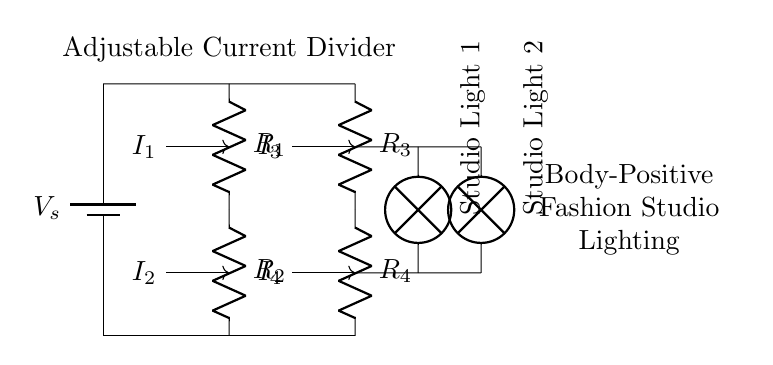What is the total number of resistors in this circuit? The diagram shows four resistors labeled as R1, R2, R3, and R4. Adding these gives a total of four resistors.
Answer: four What is the purpose of the current divider in this circuit? A current divider allows the current to be split between different branches. In this case, it adjusts the intensity of the studio lights based on the resistors' values.
Answer: adjust lighting Which component receives the most current in this circuit? Without specific resistance values, the resistor with the least resistance value would receive the most current. However, it's typically determined by their relative values.
Answer: R with least resistance How many studio lights are connected in the circuit? The diagram shows two studio lights, labeled as Studio Light 1 and Studio Light 2, indicating there are two connected in the circuit.
Answer: two Which resistors are in series with each other? R1 and R2 are in series since they are connected consecutively on the same branch. Similarly, R3 and R4 are also in series.
Answer: R1 and R2; R3 and R4 What happens to the current through each light if one of the resistors is increased? Increasing the resistance of one of the resistors would reduce the total current through that branch, affecting the current distributed to the lights and reducing their intensity.
Answer: decreases intensity How can the lighting intensity in this circuit be adjusted? The lighting intensity can be adjusted by changing the resistance values of the resistors in the circuit. This would manipulate the current flowing through each light.
Answer: change resistor values 